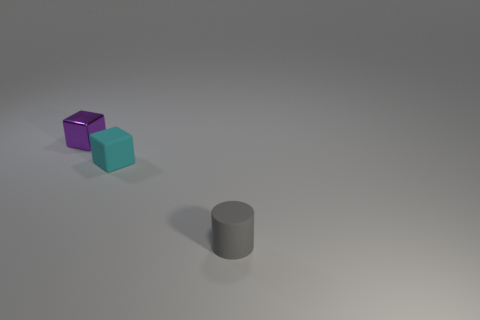Add 3 cyan rubber objects. How many objects exist? 6 Subtract all cylinders. How many objects are left? 2 Subtract 0 brown cubes. How many objects are left? 3 Subtract all tiny cyan objects. Subtract all tiny metal cubes. How many objects are left? 1 Add 1 small cubes. How many small cubes are left? 3 Add 2 green cylinders. How many green cylinders exist? 2 